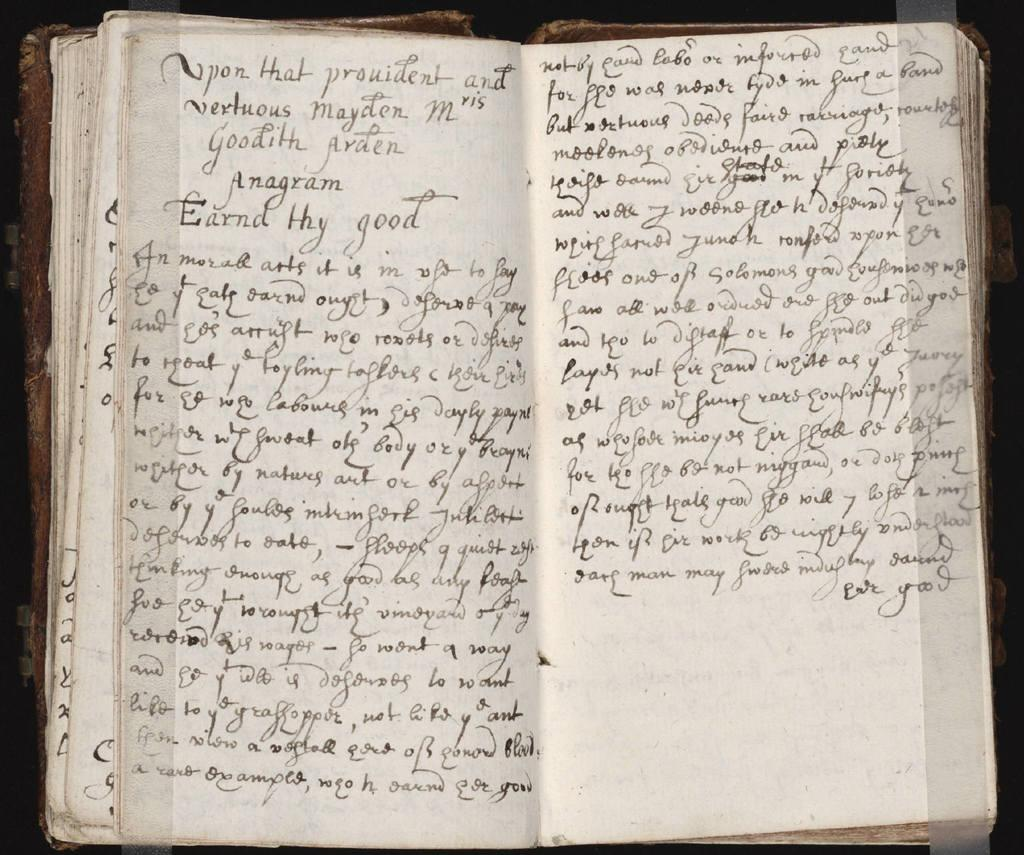<image>
Relay a brief, clear account of the picture shown. A book that is written in old English starts with Upon that provident. 